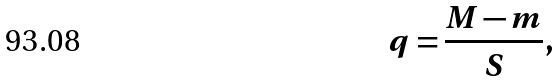<formula> <loc_0><loc_0><loc_500><loc_500>q = \frac { M - m } { S } ,</formula> 